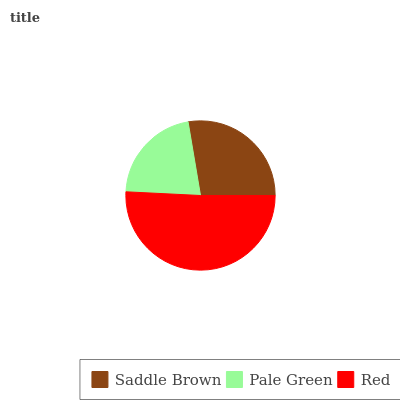Is Pale Green the minimum?
Answer yes or no. Yes. Is Red the maximum?
Answer yes or no. Yes. Is Red the minimum?
Answer yes or no. No. Is Pale Green the maximum?
Answer yes or no. No. Is Red greater than Pale Green?
Answer yes or no. Yes. Is Pale Green less than Red?
Answer yes or no. Yes. Is Pale Green greater than Red?
Answer yes or no. No. Is Red less than Pale Green?
Answer yes or no. No. Is Saddle Brown the high median?
Answer yes or no. Yes. Is Saddle Brown the low median?
Answer yes or no. Yes. Is Pale Green the high median?
Answer yes or no. No. Is Pale Green the low median?
Answer yes or no. No. 